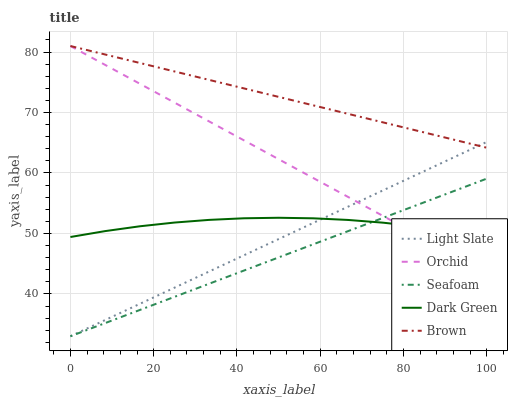Does Seafoam have the minimum area under the curve?
Answer yes or no. Yes. Does Brown have the maximum area under the curve?
Answer yes or no. Yes. Does Dark Green have the minimum area under the curve?
Answer yes or no. No. Does Dark Green have the maximum area under the curve?
Answer yes or no. No. Is Light Slate the smoothest?
Answer yes or no. Yes. Is Dark Green the roughest?
Answer yes or no. Yes. Is Brown the smoothest?
Answer yes or no. No. Is Brown the roughest?
Answer yes or no. No. Does Dark Green have the lowest value?
Answer yes or no. No. Does Orchid have the highest value?
Answer yes or no. Yes. Does Dark Green have the highest value?
Answer yes or no. No. Is Seafoam less than Brown?
Answer yes or no. Yes. Is Brown greater than Seafoam?
Answer yes or no. Yes. Does Light Slate intersect Dark Green?
Answer yes or no. Yes. Is Light Slate less than Dark Green?
Answer yes or no. No. Is Light Slate greater than Dark Green?
Answer yes or no. No. Does Seafoam intersect Brown?
Answer yes or no. No. 